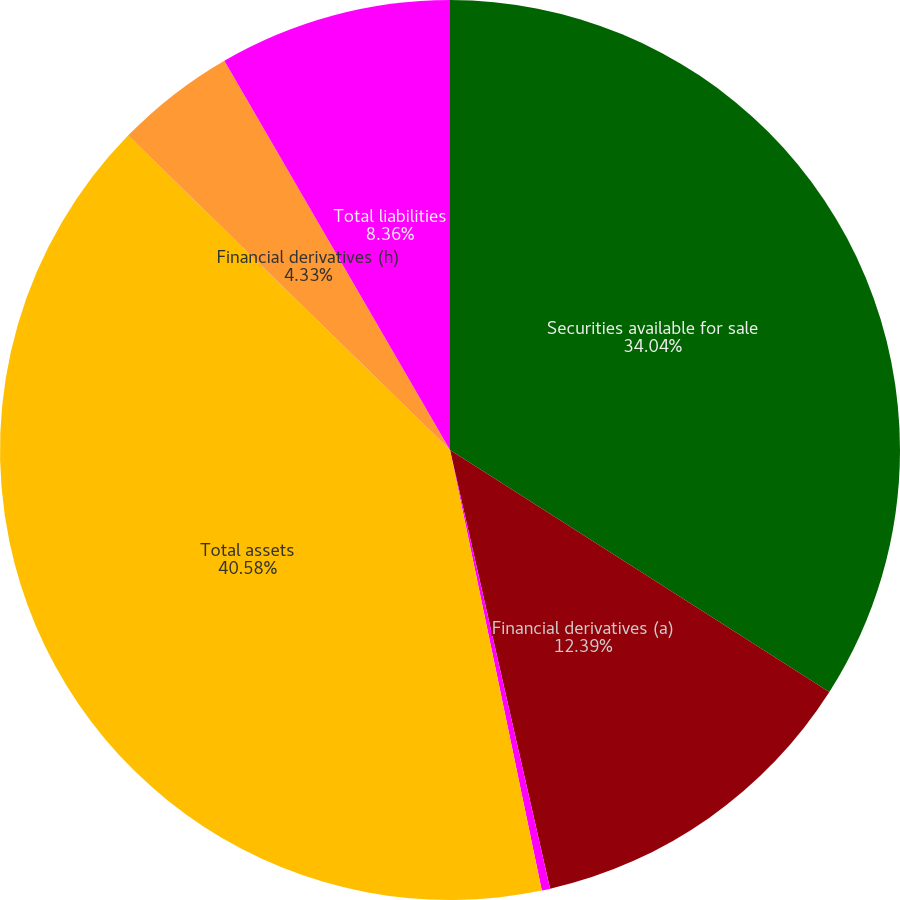Convert chart to OTSL. <chart><loc_0><loc_0><loc_500><loc_500><pie_chart><fcel>Securities available for sale<fcel>Financial derivatives (a)<fcel>Trading securities (c)<fcel>Total assets<fcel>Financial derivatives (h)<fcel>Total liabilities<nl><fcel>34.04%<fcel>12.39%<fcel>0.3%<fcel>40.58%<fcel>4.33%<fcel>8.36%<nl></chart> 